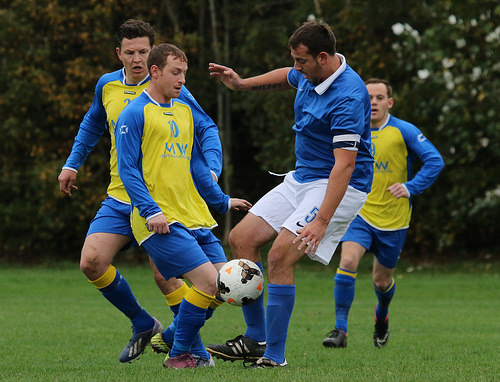<image>
Can you confirm if the soccer ball is on the grass? No. The soccer ball is not positioned on the grass. They may be near each other, but the soccer ball is not supported by or resting on top of the grass. 